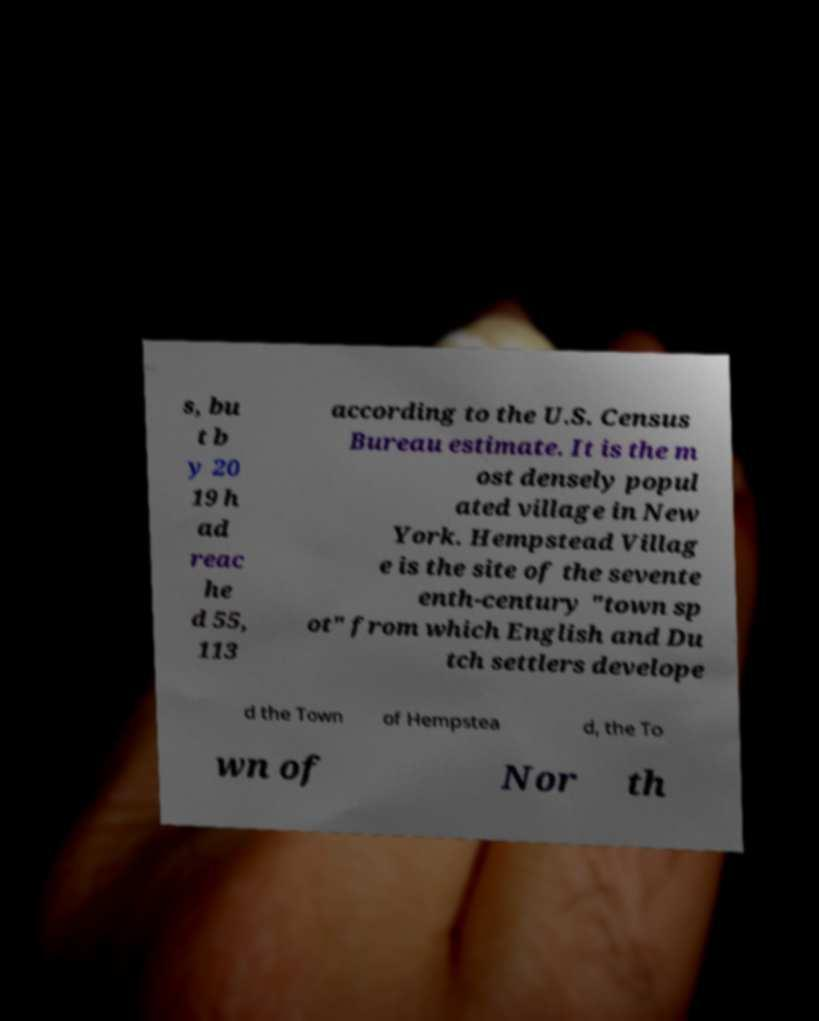Please read and relay the text visible in this image. What does it say? s, bu t b y 20 19 h ad reac he d 55, 113 according to the U.S. Census Bureau estimate. It is the m ost densely popul ated village in New York. Hempstead Villag e is the site of the sevente enth-century "town sp ot" from which English and Du tch settlers develope d the Town of Hempstea d, the To wn of Nor th 